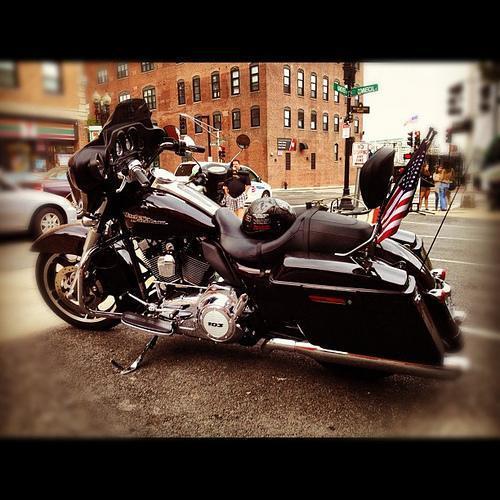How many people are in the background?
Give a very brief answer. 5. How many flags are there?
Give a very brief answer. 1. 